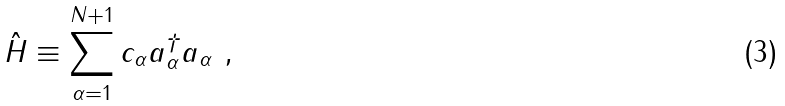<formula> <loc_0><loc_0><loc_500><loc_500>\hat { H } \equiv \sum _ { \alpha = 1 } ^ { N + 1 } c _ { \alpha } a _ { \alpha } ^ { \dagger } a _ { \alpha } \ ,</formula> 